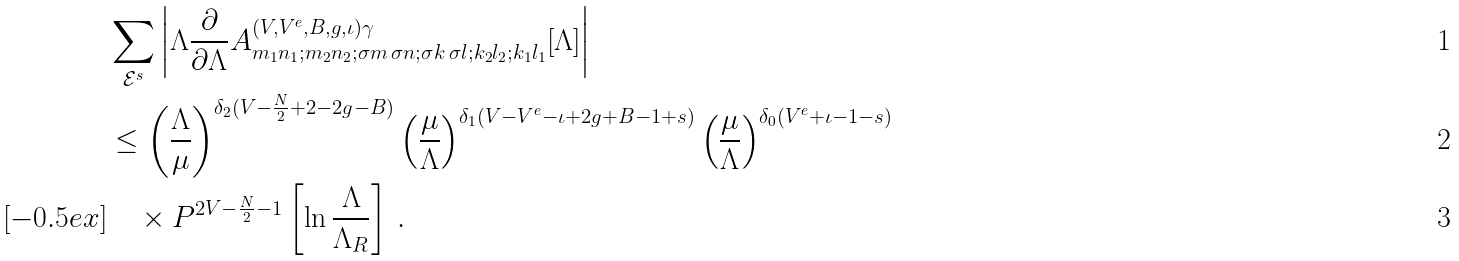Convert formula to latex. <formula><loc_0><loc_0><loc_500><loc_500>& \sum _ { \mathcal { E } ^ { s } } \left | \Lambda \frac { \partial } { \partial \Lambda } A ^ { ( V , V ^ { e } , B , g , \iota ) \gamma } _ { m _ { 1 } n _ { 1 } ; m _ { 2 } n _ { 2 } ; \sigma m \, \sigma n ; \sigma k \, \sigma l ; k _ { 2 } l _ { 2 } ; k _ { 1 } l _ { 1 } } [ \Lambda ] \right | \\ & \leq \left ( \frac { \Lambda } { \mu } \right ) ^ { \delta _ { 2 } ( V - \frac { N } { 2 } + 2 - 2 g - B ) } \left ( \frac { \mu } { \Lambda } \right ) ^ { \delta _ { 1 } ( V - V ^ { e } - \iota + 2 g + B - 1 + s ) } \left ( \frac { \mu } { \Lambda } \right ) ^ { \delta _ { 0 } ( V ^ { e } + \iota - 1 - s ) } \\ [ - 0 . 5 e x ] & \quad \times P ^ { 2 V - \frac { N } { 2 } - 1 } \left [ \ln \frac { \Lambda } { \Lambda _ { R } } \right ] \, .</formula> 